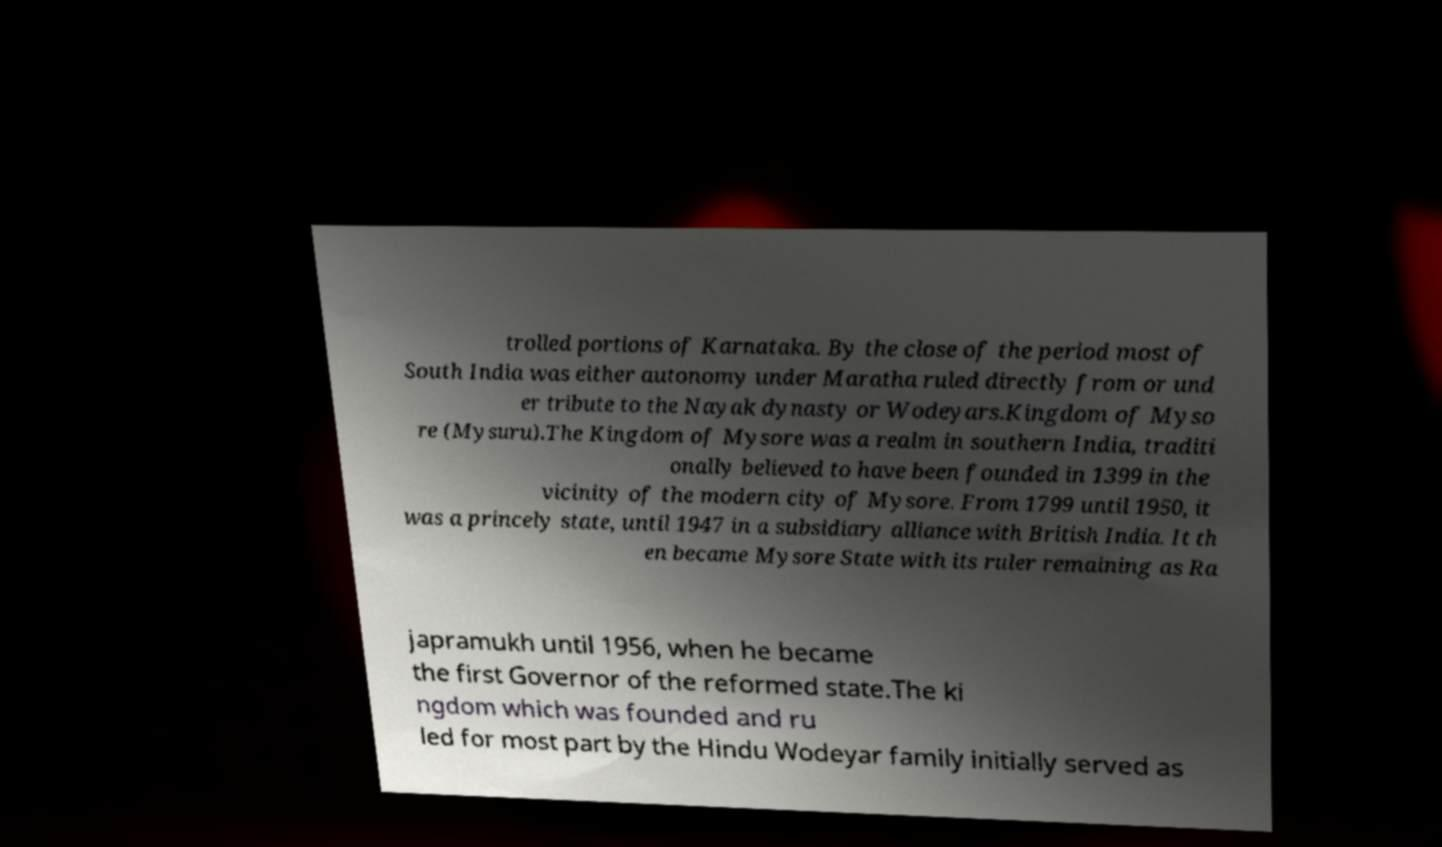Can you read and provide the text displayed in the image?This photo seems to have some interesting text. Can you extract and type it out for me? trolled portions of Karnataka. By the close of the period most of South India was either autonomy under Maratha ruled directly from or und er tribute to the Nayak dynasty or Wodeyars.Kingdom of Myso re (Mysuru).The Kingdom of Mysore was a realm in southern India, traditi onally believed to have been founded in 1399 in the vicinity of the modern city of Mysore. From 1799 until 1950, it was a princely state, until 1947 in a subsidiary alliance with British India. It th en became Mysore State with its ruler remaining as Ra japramukh until 1956, when he became the first Governor of the reformed state.The ki ngdom which was founded and ru led for most part by the Hindu Wodeyar family initially served as 